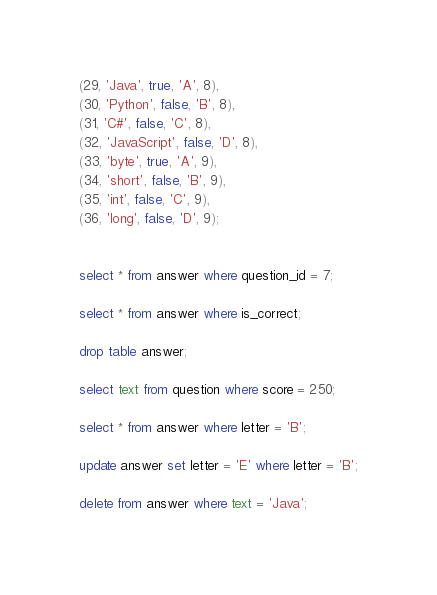<code> <loc_0><loc_0><loc_500><loc_500><_SQL_>(29, 'Java', true, 'A', 8),
(30, 'Python', false, 'B', 8),
(31, 'C#', false, 'C', 8),
(32, 'JavaScript', false, 'D', 8),
(33, 'byte', true, 'A', 9),
(34, 'short', false, 'B', 9),
(35, 'int', false, 'C', 9),
(36, 'long', false, 'D', 9);


select * from answer where question_id = 7;

select * from answer where is_correct;

drop table answer;

select text from question where score = 250;

select * from answer where letter = 'B';

update answer set letter = 'E' where letter = 'B';

delete from answer where text = 'Java';</code> 